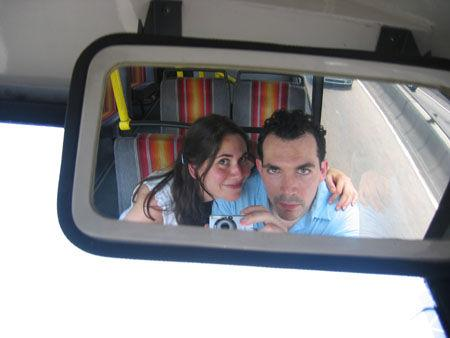They are taking this photo in what? mirror 